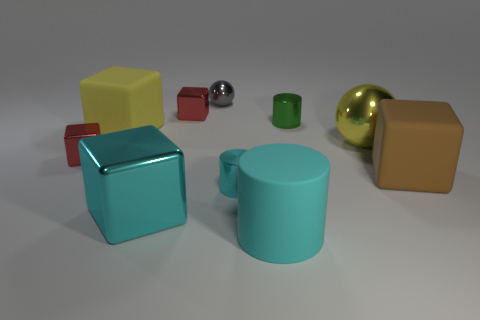What number of matte cubes have the same size as the gray sphere? Upon inspecting the image, there are no matte cubes that are of the exact same size as the gray sphere. The various cubes and spheres in the image vary in size and color, hence the accurate count of cubes same in size as the gray sphere is zero. 